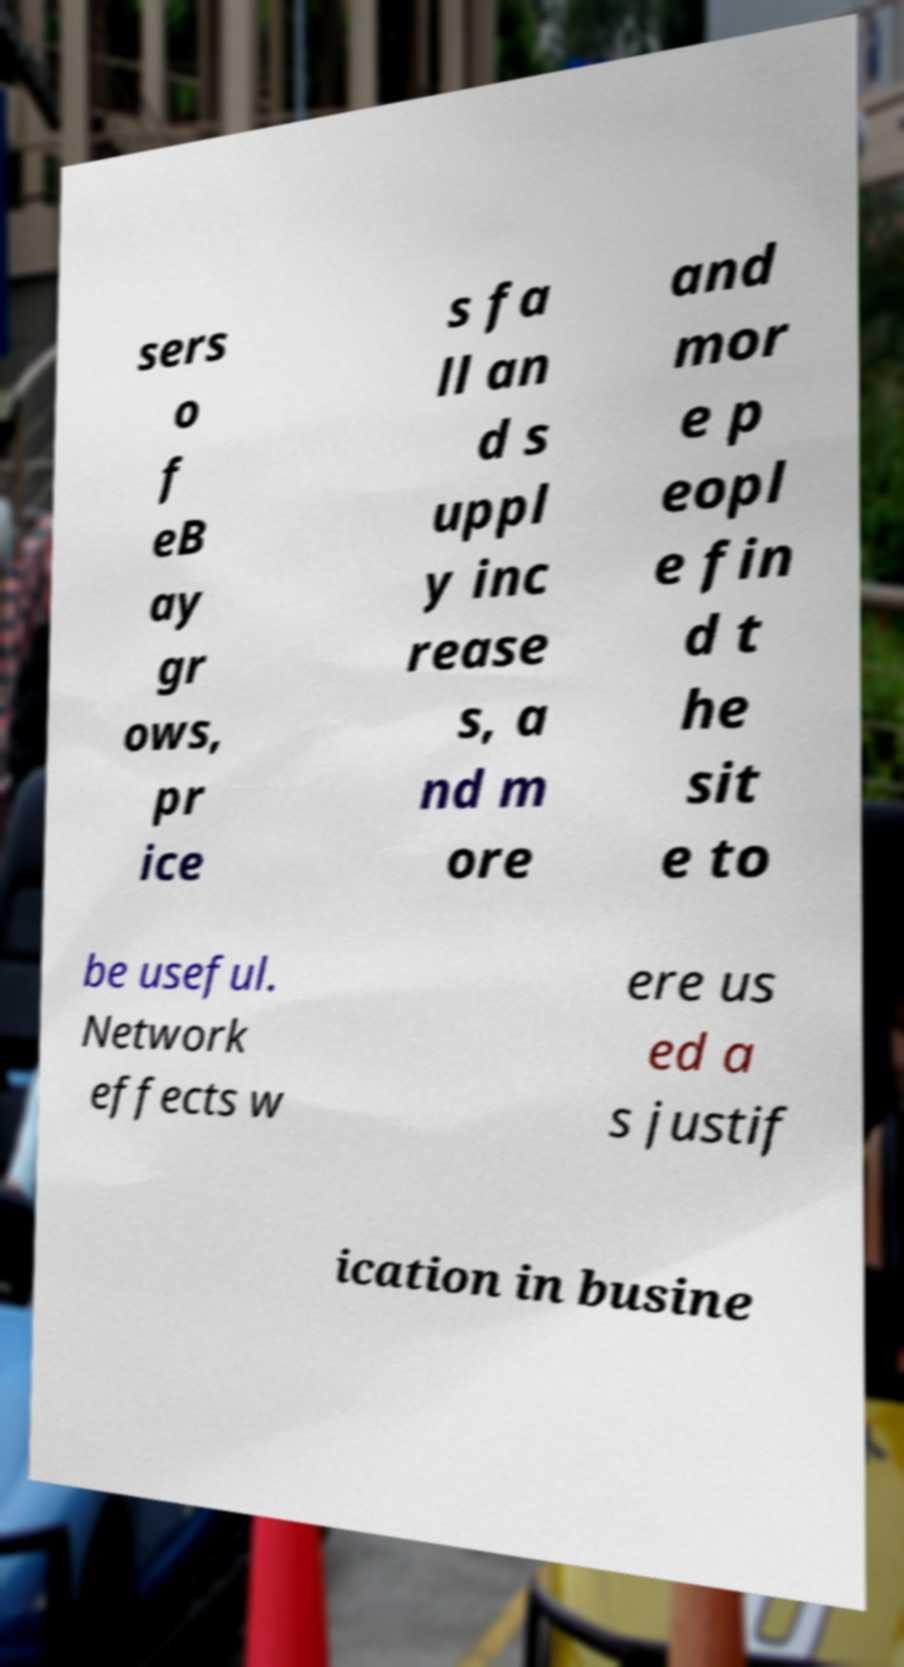Can you read and provide the text displayed in the image?This photo seems to have some interesting text. Can you extract and type it out for me? sers o f eB ay gr ows, pr ice s fa ll an d s uppl y inc rease s, a nd m ore and mor e p eopl e fin d t he sit e to be useful. Network effects w ere us ed a s justif ication in busine 